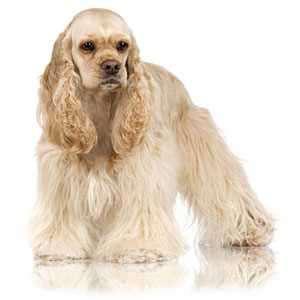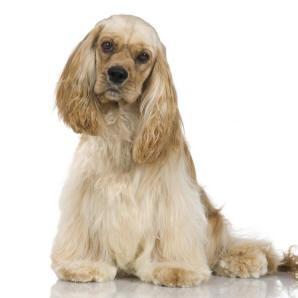The first image is the image on the left, the second image is the image on the right. Evaluate the accuracy of this statement regarding the images: "the dog in the image on the left is in side profile". Is it true? Answer yes or no. No. 